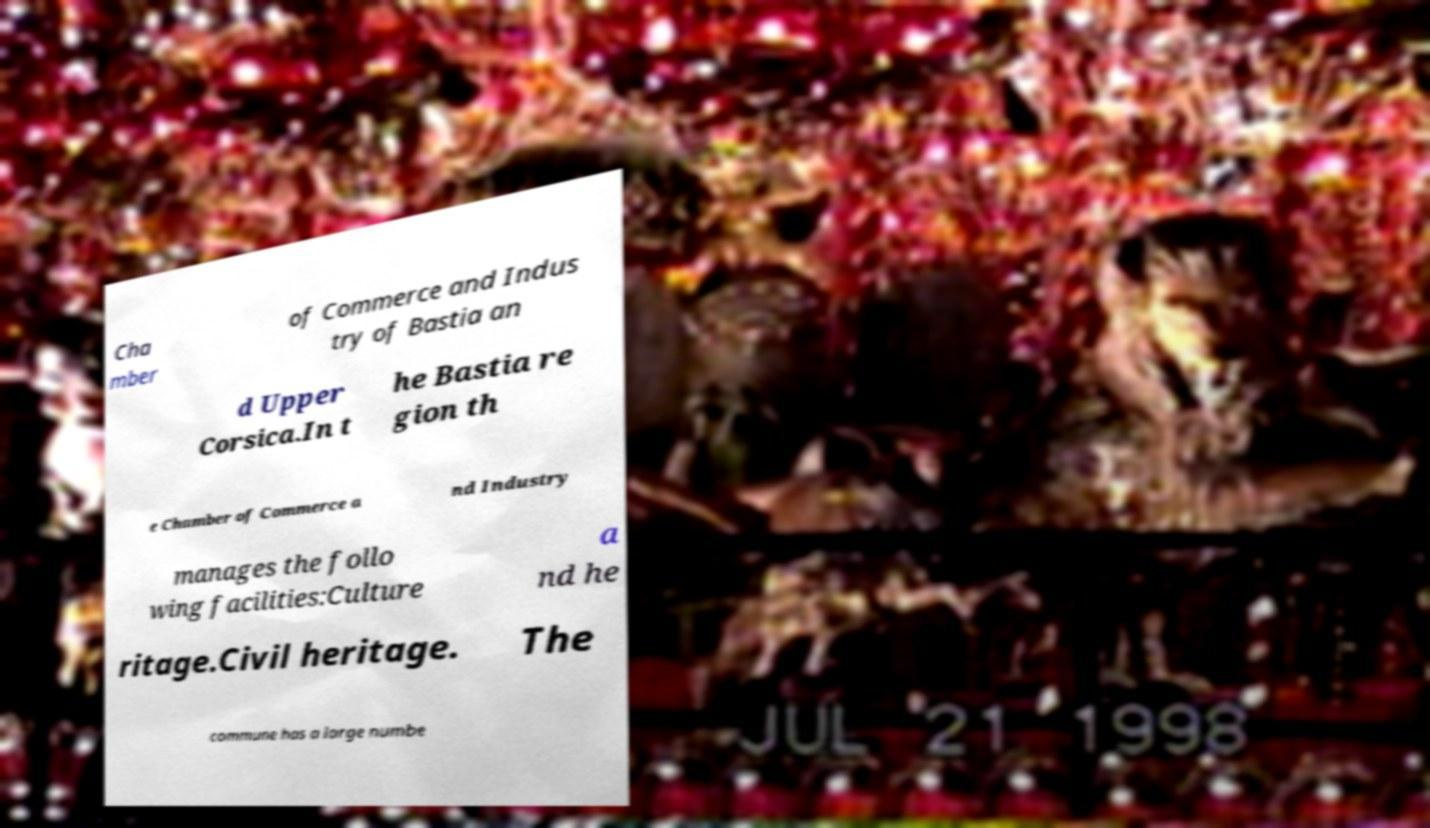Please identify and transcribe the text found in this image. Cha mber of Commerce and Indus try of Bastia an d Upper Corsica.In t he Bastia re gion th e Chamber of Commerce a nd Industry manages the follo wing facilities:Culture a nd he ritage.Civil heritage. The commune has a large numbe 